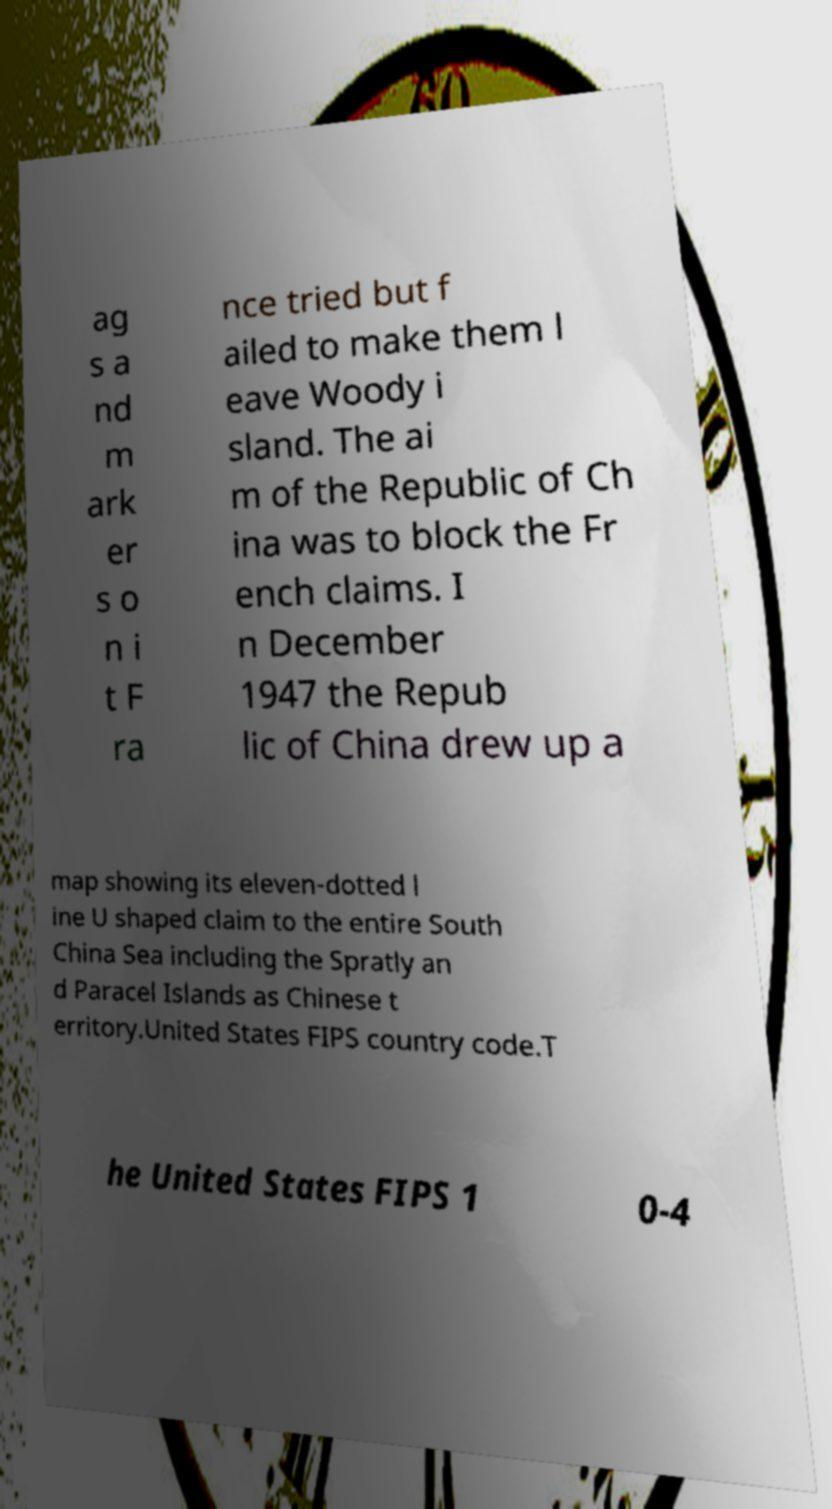What messages or text are displayed in this image? I need them in a readable, typed format. ag s a nd m ark er s o n i t F ra nce tried but f ailed to make them l eave Woody i sland. The ai m of the Republic of Ch ina was to block the Fr ench claims. I n December 1947 the Repub lic of China drew up a map showing its eleven-dotted l ine U shaped claim to the entire South China Sea including the Spratly an d Paracel Islands as Chinese t erritory.United States FIPS country code.T he United States FIPS 1 0-4 